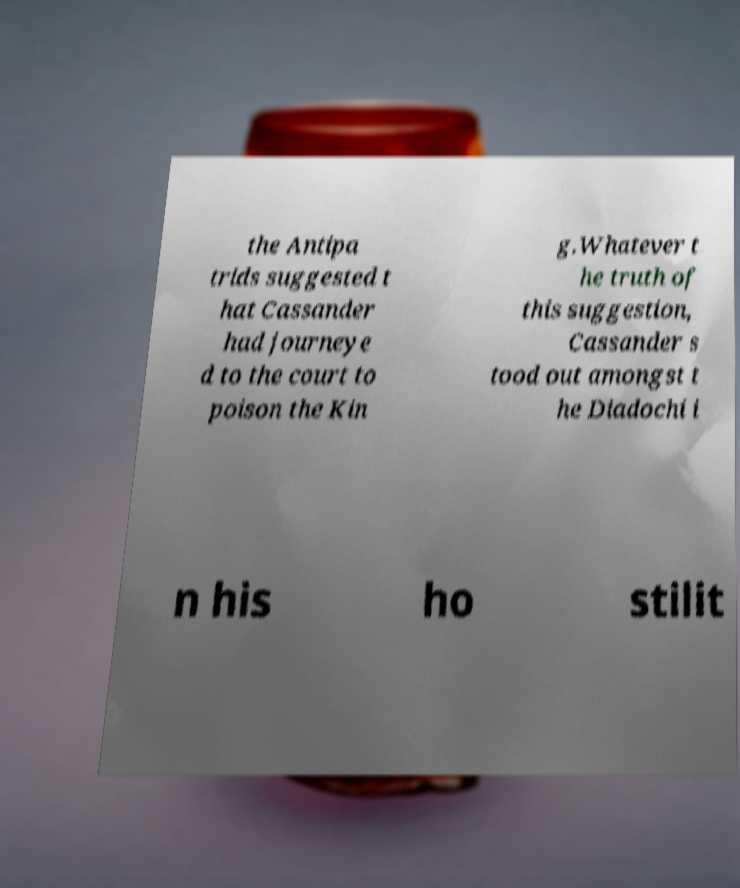For documentation purposes, I need the text within this image transcribed. Could you provide that? the Antipa trids suggested t hat Cassander had journeye d to the court to poison the Kin g.Whatever t he truth of this suggestion, Cassander s tood out amongst t he Diadochi i n his ho stilit 